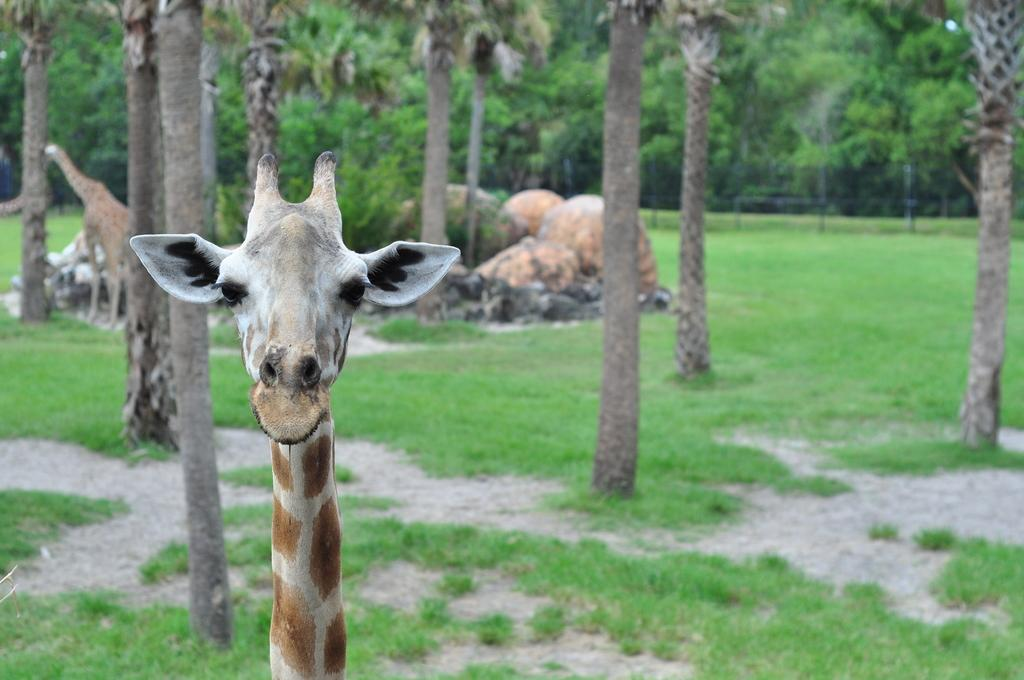What animals can be seen in the image? There are giraffes in the image. What can be seen in the background of the image? There are trees, a fence, and rocks in the background of the image. What is covering the ground at the bottom of the image? The ground is covered with grass at the bottom of the image. What type of sweater is the giraffe wearing in the image? There are no sweaters present in the image, as giraffes are animals and do not wear clothing. 